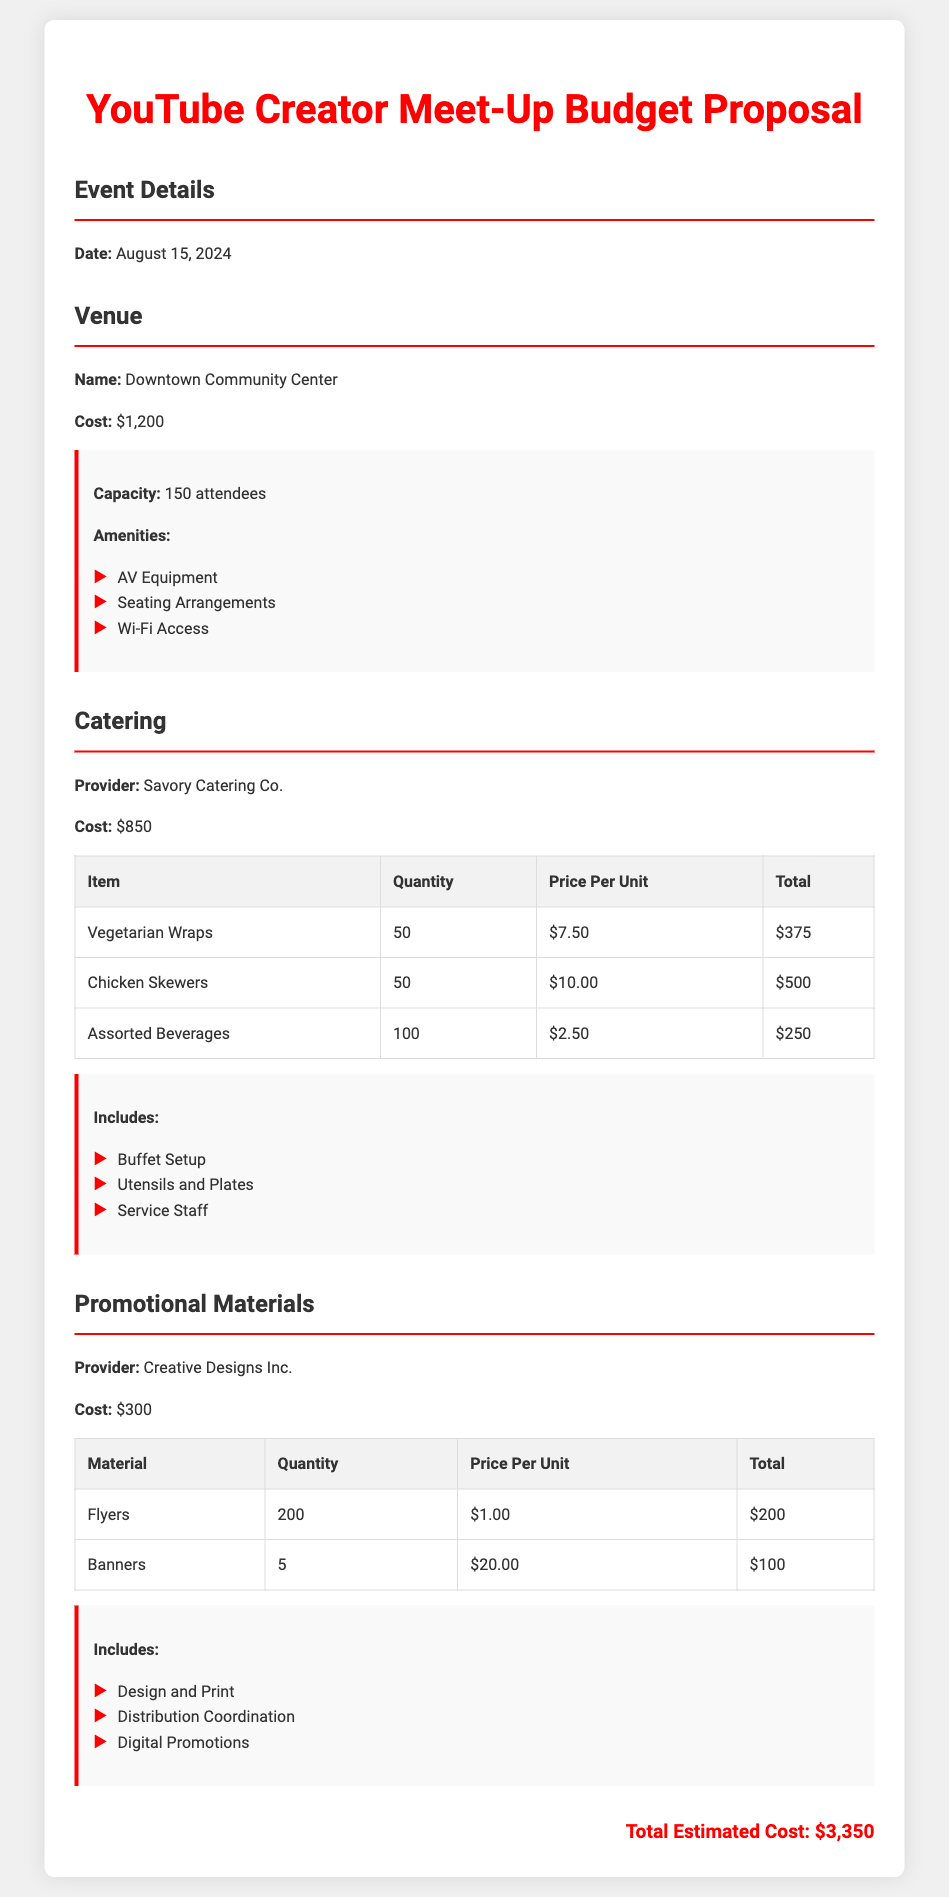what is the date of the event? The event is scheduled for August 15, 2024.
Answer: August 15, 2024 what is the venue name? The venue for the meet-up is the Downtown Community Center.
Answer: Downtown Community Center how much does the catering cost? The total cost for catering provided by Savory Catering Co. is $850.
Answer: $850 how many attendees can the venue accommodate? The capacity of the Downtown Community Center is 150 attendees.
Answer: 150 attendees what is included in the catering services? The catering services include buffet setup, utensils and plates, and service staff.
Answer: Buffet Setup, Utensils and Plates, Service Staff what is the total estimated cost of the meet-up? The total estimated cost combines all expenses listed, which sum up to $3,350.
Answer: $3,350 how many flyers are being printed? The number of flyers being printed is 200.
Answer: 200 who provides the promotional materials? The promotional materials are provided by Creative Designs Inc.
Answer: Creative Designs Inc what is the cost of the venue? The cost associated with the venue is $1,200.
Answer: $1,200 